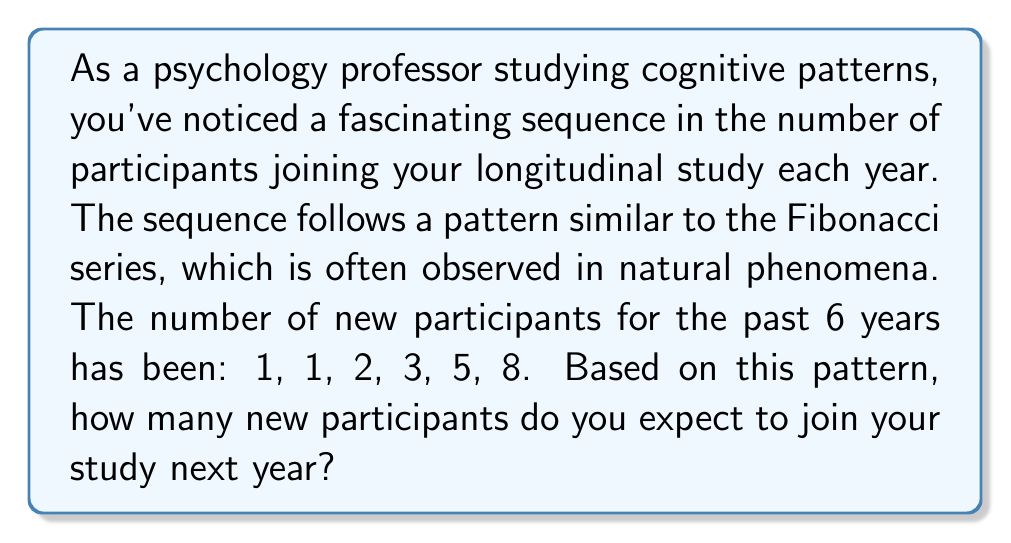Can you solve this math problem? To solve this problem, let's follow these steps:

1. Recognize the pattern:
   The given sequence (1, 1, 2, 3, 5, 8) follows the Fibonacci series.

2. Understand the Fibonacci rule:
   Each number in the sequence is the sum of the two preceding numbers.
   $$F_n = F_{n-1} + F_{n-2}$$

3. Verify the pattern for the given sequence:
   $1 + 1 = 2$
   $1 + 2 = 3$
   $2 + 3 = 5$
   $3 + 5 = 8$

4. Calculate the next number:
   The next number will be the sum of the last two numbers in the sequence.
   $$5 + 8 = 13$$

Therefore, based on the Fibonacci pattern observed in the past 6 years, you can expect 13 new participants to join your study next year.
Answer: 13 